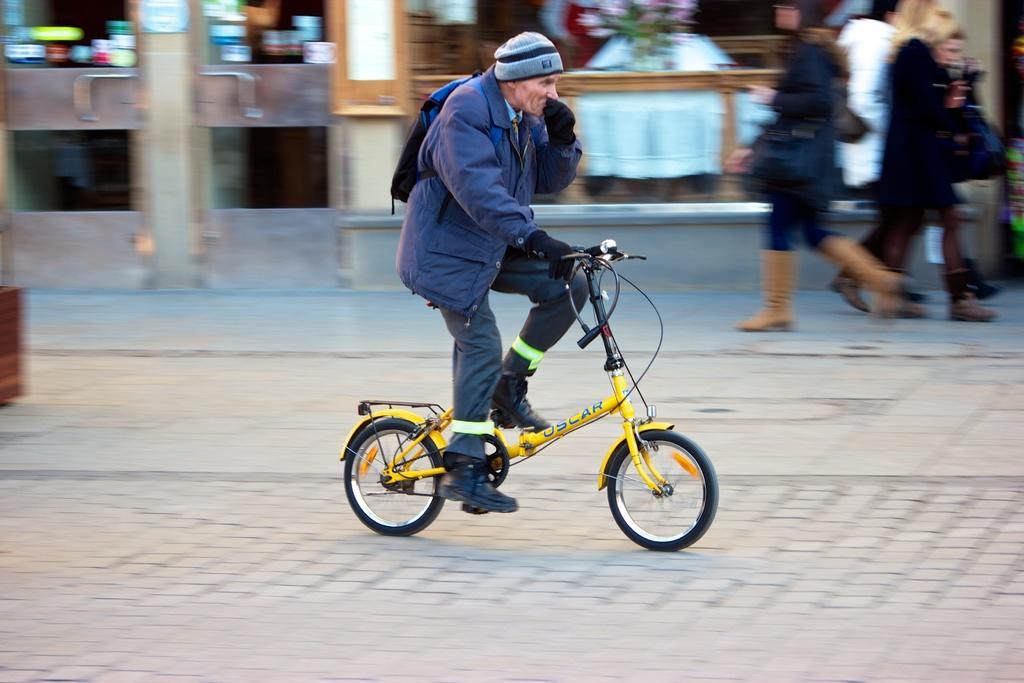How would you summarize this image in a sentence or two? A man with blue jacket is sitting on a cycle and riding on the road. In the background there are some people walking on the footpath. And we can see some door and stores. 